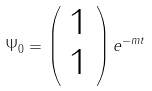<formula> <loc_0><loc_0><loc_500><loc_500>\Psi _ { 0 } = \left ( \begin{array} { c } 1 \\ 1 \end{array} \right ) e ^ { - m t }</formula> 